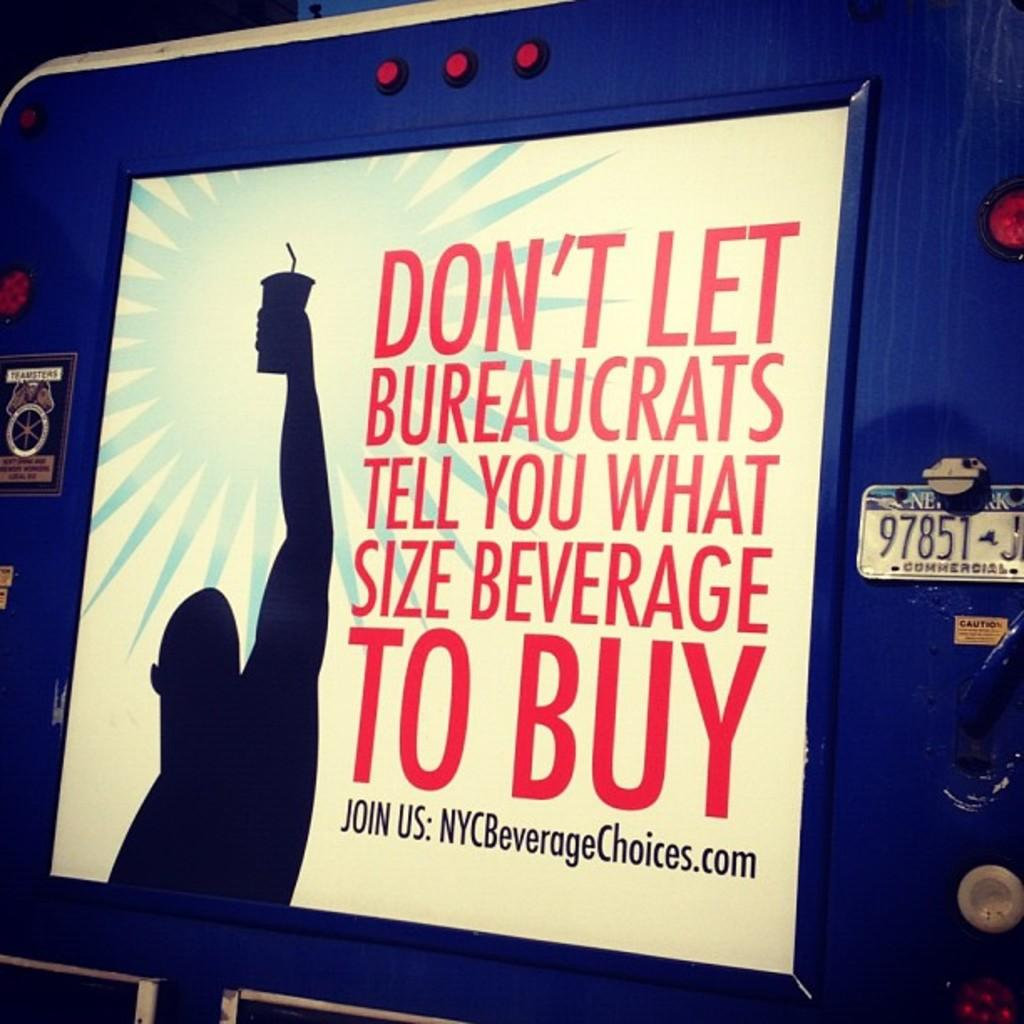<image>
Render a clear and concise summary of the photo. a framed poster that says 'don't let bureaucrats tell you what size beverage to buy' on it 